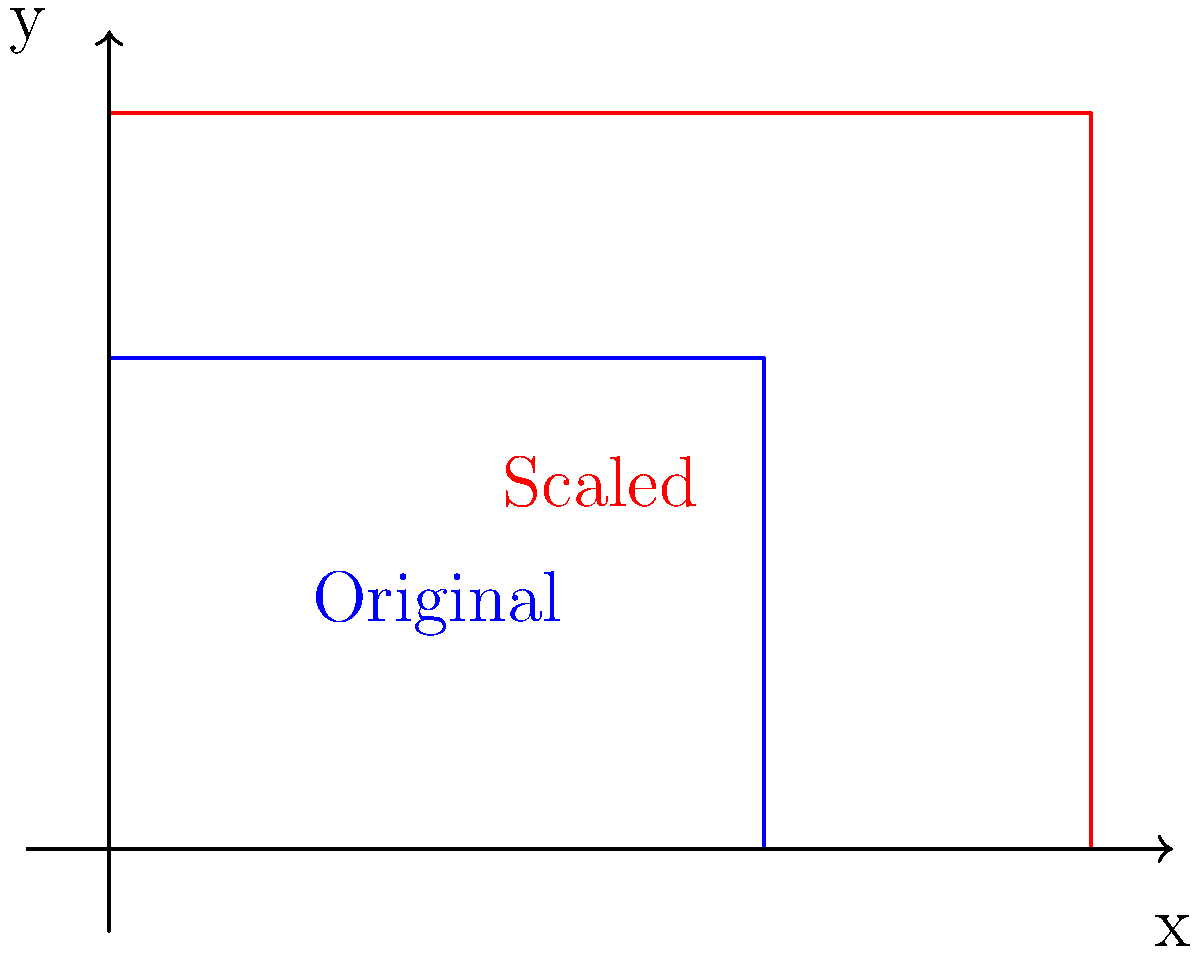As a solutions architect, you're designing a system that processes and scales 2D images. Given a rectangular image with dimensions 4 units by 3 units, if you scale it uniformly by a factor of 1.5, what is the percentage increase in the image's area? Express your answer as a percentage rounded to the nearest whole number. To solve this problem, let's follow these steps:

1. Calculate the original area:
   Original area = $4 \times 3 = 12$ square units

2. Calculate the new dimensions after scaling:
   New width = $4 \times 1.5 = 6$ units
   New height = $3 \times 1.5 = 4.5$ units

3. Calculate the new area:
   New area = $6 \times 4.5 = 27$ square units

4. Calculate the increase in area:
   Increase = New area - Original area
   Increase = $27 - 12 = 15$ square units

5. Calculate the percentage increase:
   Percentage increase = $\frac{\text{Increase}}{\text{Original area}} \times 100\%$
   Percentage increase = $\frac{15}{12} \times 100\% = 125\%$

6. Round to the nearest whole number:
   125% (no rounding needed in this case)

This result aligns with the scaling factor squared: $(1.5)^2 = 2.25$, which represents a 125% increase.
Answer: 125% 